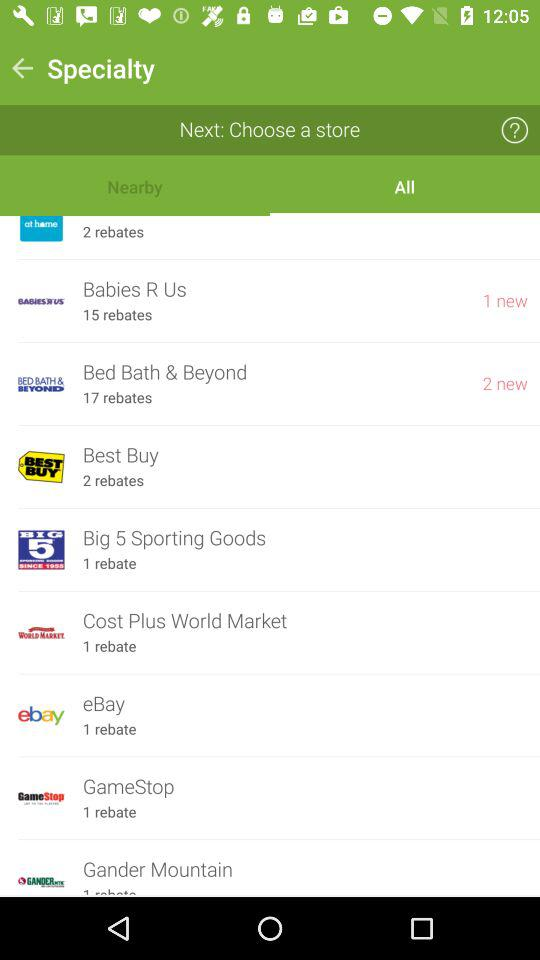How many rebates are available for GameStop?
Answer the question using a single word or phrase. 1 